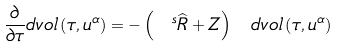Convert formula to latex. <formula><loc_0><loc_0><loc_500><loc_500>\frac { \partial } { \partial \tau } d v o l \left ( \tau , u ^ { \alpha } \right ) = - \left ( \ ^ { s } \widehat { R } + Z \right ) \ d v o l \left ( \tau , u ^ { \alpha } \right )</formula> 